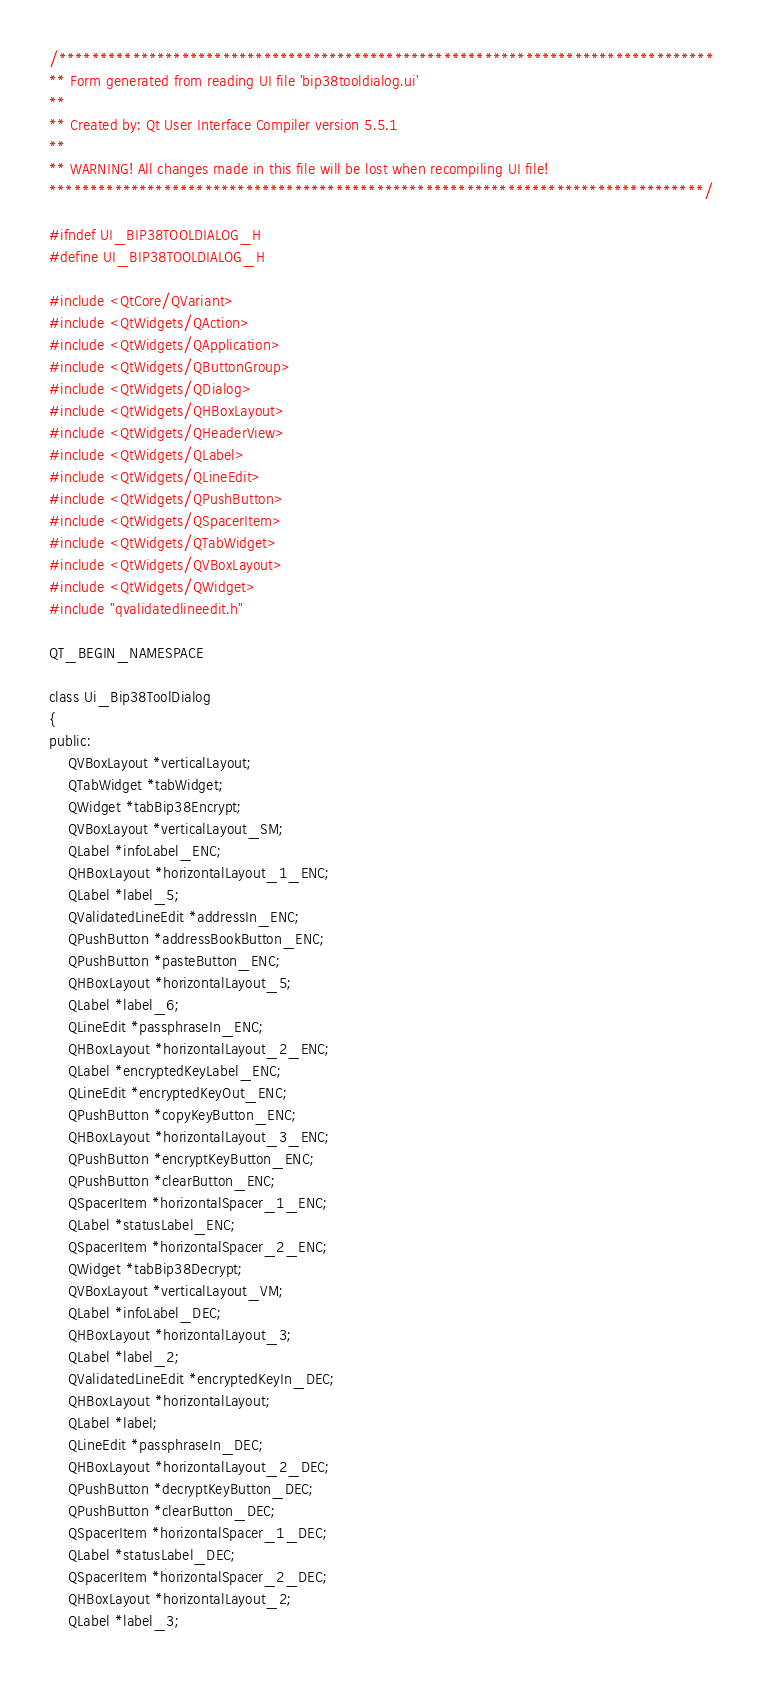Convert code to text. <code><loc_0><loc_0><loc_500><loc_500><_C_>/********************************************************************************
** Form generated from reading UI file 'bip38tooldialog.ui'
**
** Created by: Qt User Interface Compiler version 5.5.1
**
** WARNING! All changes made in this file will be lost when recompiling UI file!
********************************************************************************/

#ifndef UI_BIP38TOOLDIALOG_H
#define UI_BIP38TOOLDIALOG_H

#include <QtCore/QVariant>
#include <QtWidgets/QAction>
#include <QtWidgets/QApplication>
#include <QtWidgets/QButtonGroup>
#include <QtWidgets/QDialog>
#include <QtWidgets/QHBoxLayout>
#include <QtWidgets/QHeaderView>
#include <QtWidgets/QLabel>
#include <QtWidgets/QLineEdit>
#include <QtWidgets/QPushButton>
#include <QtWidgets/QSpacerItem>
#include <QtWidgets/QTabWidget>
#include <QtWidgets/QVBoxLayout>
#include <QtWidgets/QWidget>
#include "qvalidatedlineedit.h"

QT_BEGIN_NAMESPACE

class Ui_Bip38ToolDialog
{
public:
    QVBoxLayout *verticalLayout;
    QTabWidget *tabWidget;
    QWidget *tabBip38Encrypt;
    QVBoxLayout *verticalLayout_SM;
    QLabel *infoLabel_ENC;
    QHBoxLayout *horizontalLayout_1_ENC;
    QLabel *label_5;
    QValidatedLineEdit *addressIn_ENC;
    QPushButton *addressBookButton_ENC;
    QPushButton *pasteButton_ENC;
    QHBoxLayout *horizontalLayout_5;
    QLabel *label_6;
    QLineEdit *passphraseIn_ENC;
    QHBoxLayout *horizontalLayout_2_ENC;
    QLabel *encryptedKeyLabel_ENC;
    QLineEdit *encryptedKeyOut_ENC;
    QPushButton *copyKeyButton_ENC;
    QHBoxLayout *horizontalLayout_3_ENC;
    QPushButton *encryptKeyButton_ENC;
    QPushButton *clearButton_ENC;
    QSpacerItem *horizontalSpacer_1_ENC;
    QLabel *statusLabel_ENC;
    QSpacerItem *horizontalSpacer_2_ENC;
    QWidget *tabBip38Decrypt;
    QVBoxLayout *verticalLayout_VM;
    QLabel *infoLabel_DEC;
    QHBoxLayout *horizontalLayout_3;
    QLabel *label_2;
    QValidatedLineEdit *encryptedKeyIn_DEC;
    QHBoxLayout *horizontalLayout;
    QLabel *label;
    QLineEdit *passphraseIn_DEC;
    QHBoxLayout *horizontalLayout_2_DEC;
    QPushButton *decryptKeyButton_DEC;
    QPushButton *clearButton_DEC;
    QSpacerItem *horizontalSpacer_1_DEC;
    QLabel *statusLabel_DEC;
    QSpacerItem *horizontalSpacer_2_DEC;
    QHBoxLayout *horizontalLayout_2;
    QLabel *label_3;</code> 